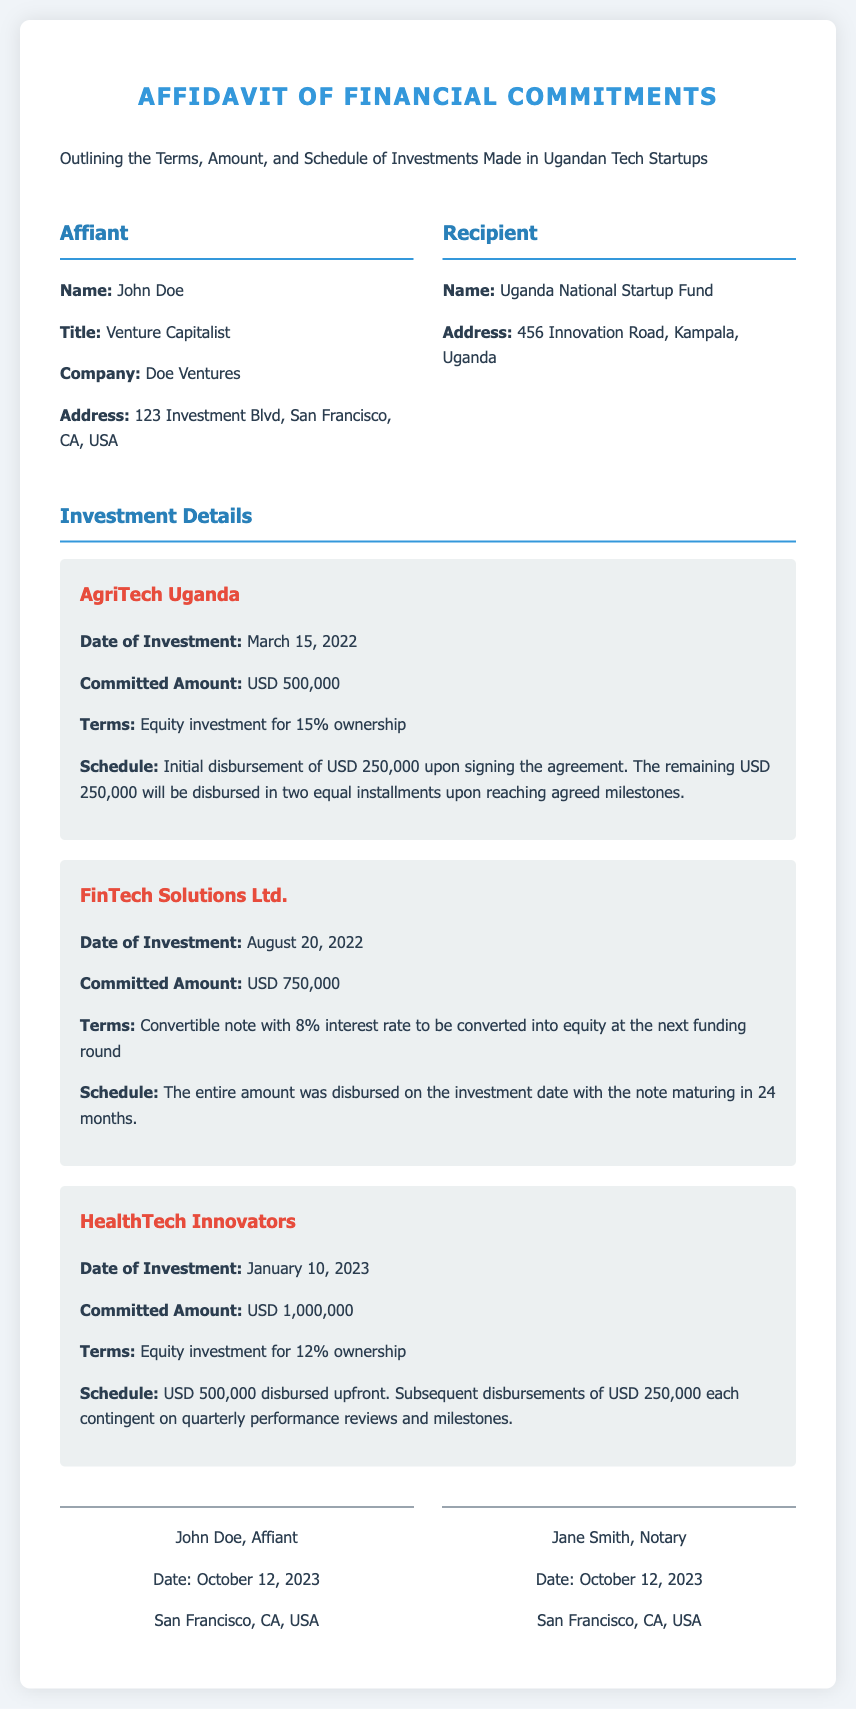What is the name of the affiant? The affiant is introduced in the document as John Doe.
Answer: John Doe What is the total committed amount for AgriTech Uganda? The committed amount for AgriTech Uganda is clearly stated in the document.
Answer: USD 500,000 When was the investment made in FinTech Solutions Ltd.? The document specifies the date of investment for FinTech Solutions Ltd.
Answer: August 20, 2022 What percentage ownership is obtained through the investment in HealthTech Innovators? The ownership percentage obtained from the investment in HealthTech Innovators is indicated.
Answer: 12% What is the interest rate for the convertible note in FinTech Solutions Ltd.? The document provides the interest rate associated with the convertible note.
Answer: 8% What is the schedule for the investment in AgriTech Uganda? The document outlines the investment schedule, detailing the disbursement process.
Answer: USD 250,000 upfront, remaining in two installments upon milestones Who notarized the affidavit? The document mentions the notary's name associated with the affidavit.
Answer: Jane Smith How much was initially disbursed for HealthTech Innovators? The document specifies the upfront amount disbursed for HealthTech Innovators.
Answer: USD 500,000 What is the title of the affiant? The affiant’s title is presented in the document.
Answer: Venture Capitalist 